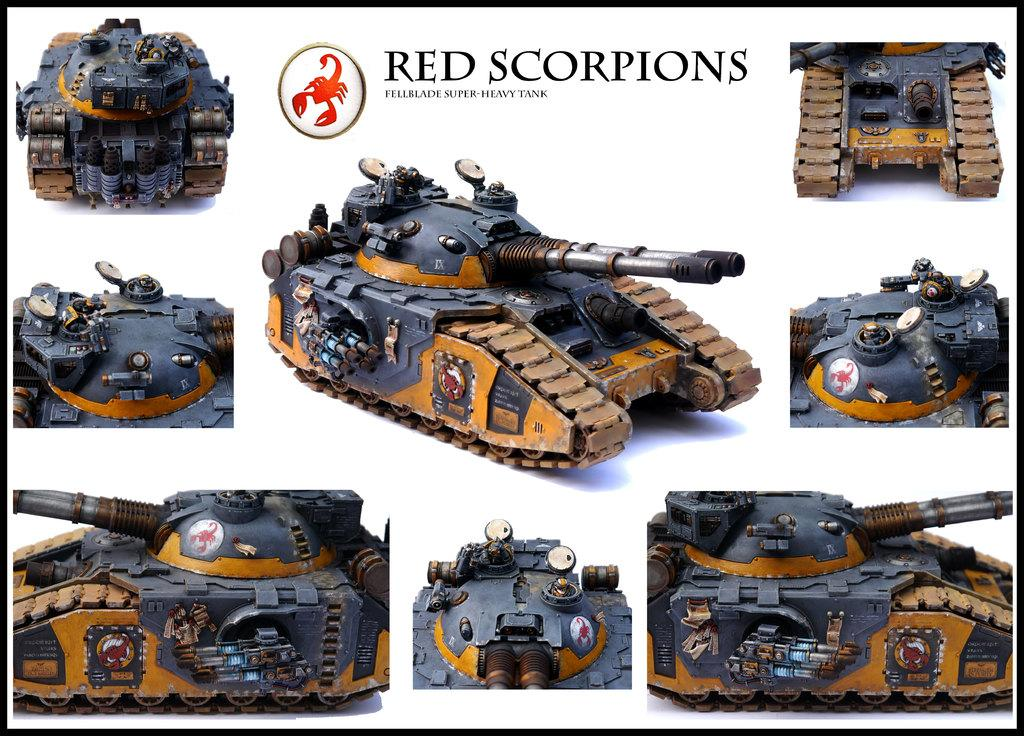What type of images are featured on the poster? The poster contains pictures of military vehicles. Is there any other element on the poster besides the images? Yes, there is a logo on the poster. Are there any words on the poster? Yes, there is text written on the poster. Where is the park located in the image? There is no park present in the image; it features pictures of military vehicles, a logo, and text. What type of wound can be seen on the poster? There is no wound depicted on the poster; it contains images of military vehicles, a logo, and text. 